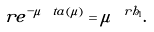Convert formula to latex. <formula><loc_0><loc_0><loc_500><loc_500>\tilde { r } e ^ { - \mu \ t a ( \mu ) } = \mu ^ { \ r h _ { 1 } } .</formula> 